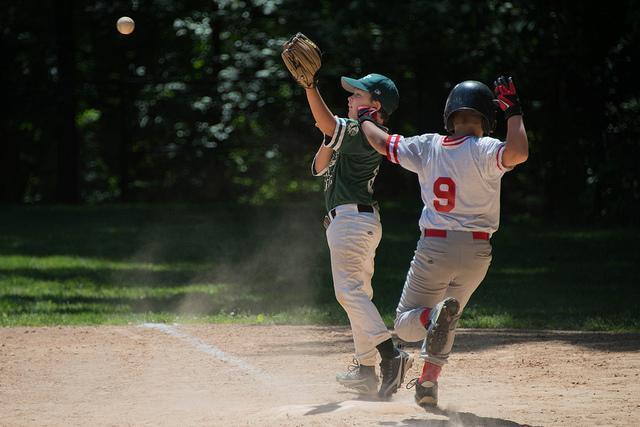How many teams are represented in the photo?
Give a very brief answer. 2. How many people are there?
Give a very brief answer. 2. 